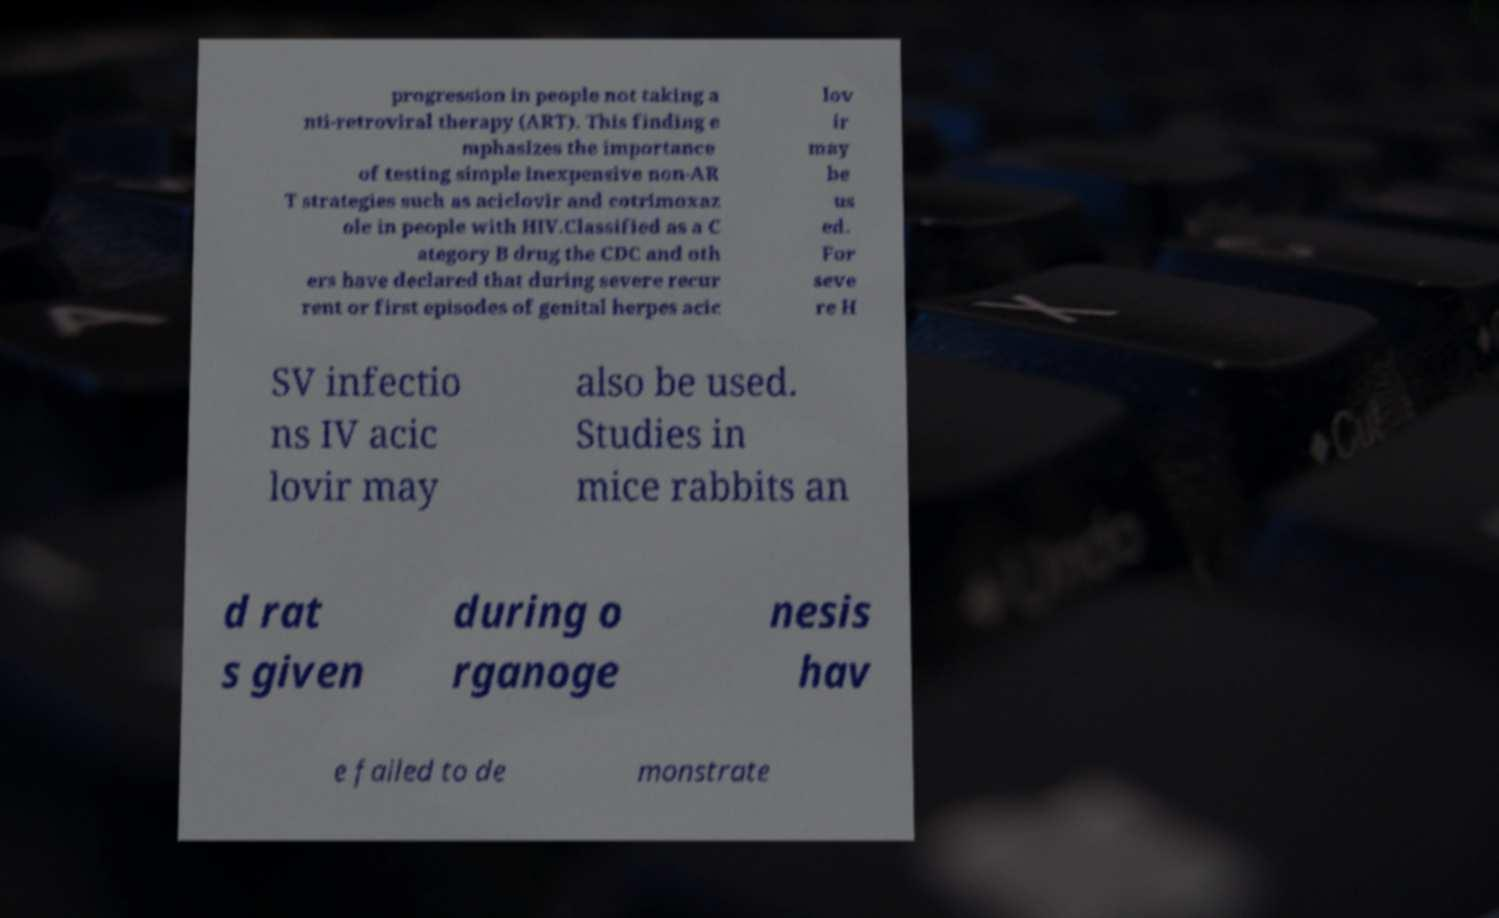For documentation purposes, I need the text within this image transcribed. Could you provide that? progression in people not taking a nti-retroviral therapy (ART). This finding e mphasizes the importance of testing simple inexpensive non-AR T strategies such as aciclovir and cotrimoxaz ole in people with HIV.Classified as a C ategory B drug the CDC and oth ers have declared that during severe recur rent or first episodes of genital herpes acic lov ir may be us ed. For seve re H SV infectio ns IV acic lovir may also be used. Studies in mice rabbits an d rat s given during o rganoge nesis hav e failed to de monstrate 